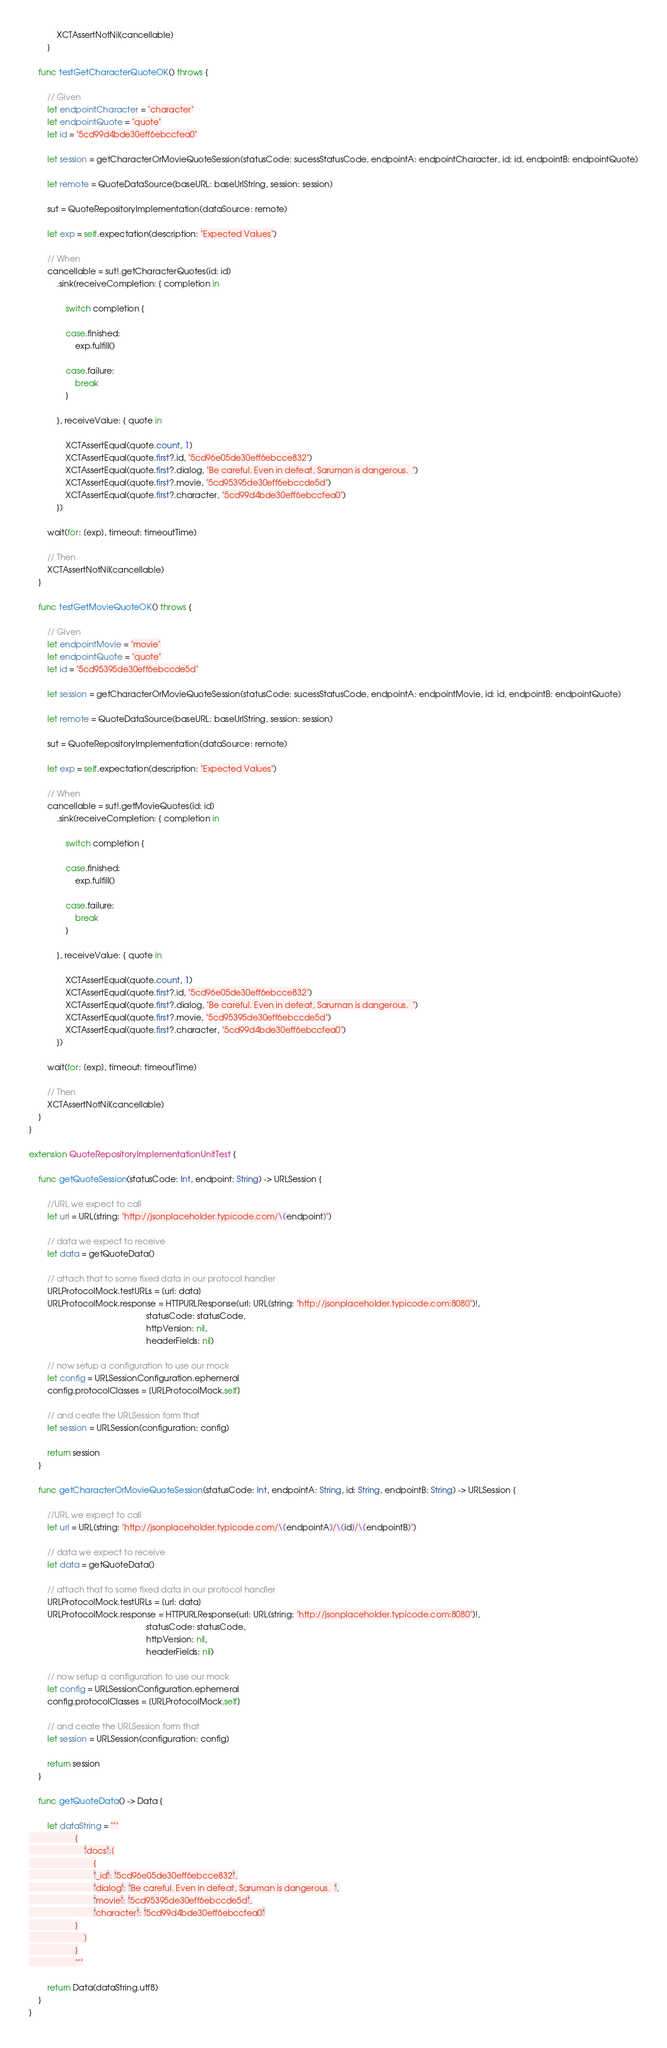Convert code to text. <code><loc_0><loc_0><loc_500><loc_500><_Swift_>            XCTAssertNotNil(cancellable)
        }
    
    func testGetCharacterQuoteOK() throws {
        
        // Given
        let endpointCharacter = "character"
        let endpointQuote = "quote"
        let id = "5cd99d4bde30eff6ebccfea0"
        
        let session = getCharacterOrMovieQuoteSession(statusCode: sucessStatusCode, endpointA: endpointCharacter, id: id, endpointB: endpointQuote)
        
        let remote = QuoteDataSource(baseURL: baseUrlString, session: session)
        
        sut = QuoteRepositoryImplementation(dataSource: remote)
        
        let exp = self.expectation(description: "Expected Values")
        
        // When
        cancellable = sut!.getCharacterQuotes(id: id)
            .sink(receiveCompletion: { completion in
                
                switch completion {
                    
                case.finished:
                    exp.fulfill()
                    
                case.failure:
                    break
                }
                
            }, receiveValue: { quote in
                
                XCTAssertEqual(quote.count, 1)
                XCTAssertEqual(quote.first?.id, "5cd96e05de30eff6ebcce832")
                XCTAssertEqual(quote.first?.dialog, "Be careful. Even in defeat, Saruman is dangerous.  ")
                XCTAssertEqual(quote.first?.movie, "5cd95395de30eff6ebccde5d")
                XCTAssertEqual(quote.first?.character, "5cd99d4bde30eff6ebccfea0")
            })
        
        wait(for: [exp], timeout: timeoutTime)
        
        // Then
        XCTAssertNotNil(cancellable)
    }
    
    func testGetMovieQuoteOK() throws {
        
        // Given
        let endpointMovie = "movie"
        let endpointQuote = "quote"
        let id = "5cd95395de30eff6ebccde5d"
        
        let session = getCharacterOrMovieQuoteSession(statusCode: sucessStatusCode, endpointA: endpointMovie, id: id, endpointB: endpointQuote)
        
        let remote = QuoteDataSource(baseURL: baseUrlString, session: session)
        
        sut = QuoteRepositoryImplementation(dataSource: remote)
        
        let exp = self.expectation(description: "Expected Values")
        
        // When
        cancellable = sut!.getMovieQuotes(id: id)
            .sink(receiveCompletion: { completion in
                
                switch completion {
                    
                case.finished:
                    exp.fulfill()
                    
                case.failure:
                    break
                }
                
            }, receiveValue: { quote in
                
                XCTAssertEqual(quote.count, 1)
                XCTAssertEqual(quote.first?.id, "5cd96e05de30eff6ebcce832")
                XCTAssertEqual(quote.first?.dialog, "Be careful. Even in defeat, Saruman is dangerous.  ")
                XCTAssertEqual(quote.first?.movie, "5cd95395de30eff6ebccde5d")
                XCTAssertEqual(quote.first?.character, "5cd99d4bde30eff6ebccfea0")
            })
        
        wait(for: [exp], timeout: timeoutTime)
        
        // Then
        XCTAssertNotNil(cancellable)
    }
}

extension QuoteRepositoryImplementationUnitTest {
    
    func getQuoteSession(statusCode: Int, endpoint: String) -> URLSession {
        
        //URL we expect to call
        let url = URL(string: "http://jsonplaceholder.typicode.com/\(endpoint)")
        
        // data we expect to receive
        let data = getQuoteData()
        
        // attach that to some fixed data in our protocol handler
        URLProtocolMock.testURLs = [url: data]
        URLProtocolMock.response = HTTPURLResponse(url: URL(string: "http://jsonplaceholder.typicode.com:8080")!,
                                                   statusCode: statusCode,
                                                   httpVersion: nil,
                                                   headerFields: nil)
        
        // now setup a configuration to use our mock
        let config = URLSessionConfiguration.ephemeral
        config.protocolClasses = [URLProtocolMock.self]
        
        // and ceate the URLSession form that
        let session = URLSession(configuration: config)
        
        return session
    }
    
    func getCharacterOrMovieQuoteSession(statusCode: Int, endpointA: String, id: String, endpointB: String) -> URLSession {
        
        //URL we expect to call
        let url = URL(string: "http://jsonplaceholder.typicode.com/\(endpointA)/\(id)/\(endpointB)")
        
        // data we expect to receive
        let data = getQuoteData()
        
        // attach that to some fixed data in our protocol handler
        URLProtocolMock.testURLs = [url: data]
        URLProtocolMock.response = HTTPURLResponse(url: URL(string: "http://jsonplaceholder.typicode.com:8080")!,
                                                   statusCode: statusCode,
                                                   httpVersion: nil,
                                                   headerFields: nil)
        
        // now setup a configuration to use our mock
        let config = URLSessionConfiguration.ephemeral
        config.protocolClasses = [URLProtocolMock.self]
        
        // and ceate the URLSession form that
        let session = URLSession(configuration: config)
        
        return session
    }
    
    func getQuoteData() -> Data {
        
        let dataString = """
                    {
                        "docs":[
                            {
                            "_id": "5cd96e05de30eff6ebcce832",
                            "dialog": "Be careful. Even in defeat, Saruman is dangerous.  ",
                            "movie": "5cd95395de30eff6ebccde5d",
                            "character": "5cd99d4bde30eff6ebccfea0"
                    }
                        ]
                    }
                    """
        
        return Data(dataString.utf8)
    }
}

</code> 